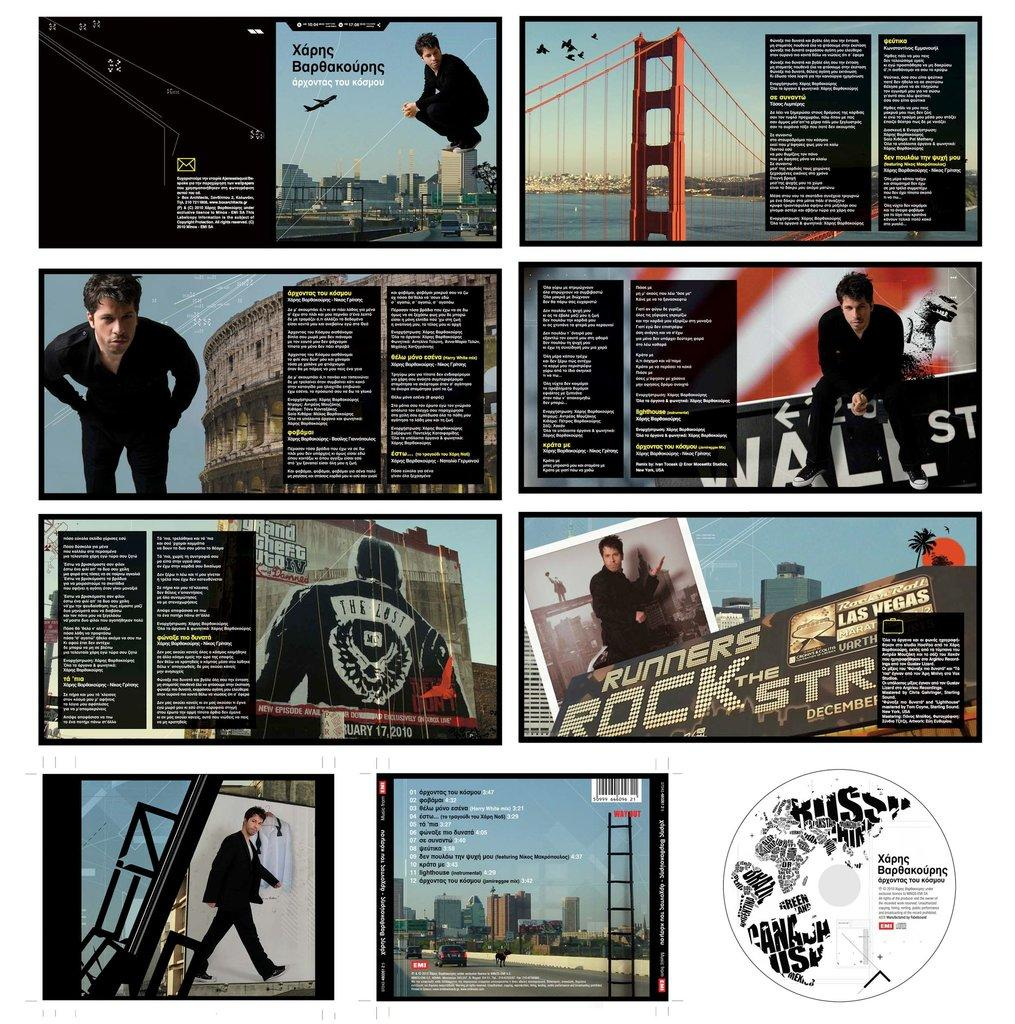What type of oil is being used to polish the boot in the image? There is no boot or oil present in the image, as it is a collage with unknown contents. How many cacti can be seen growing inside the boot in the image? There is no boot or cacti present in the image, as it is a collage with unknown contents. 